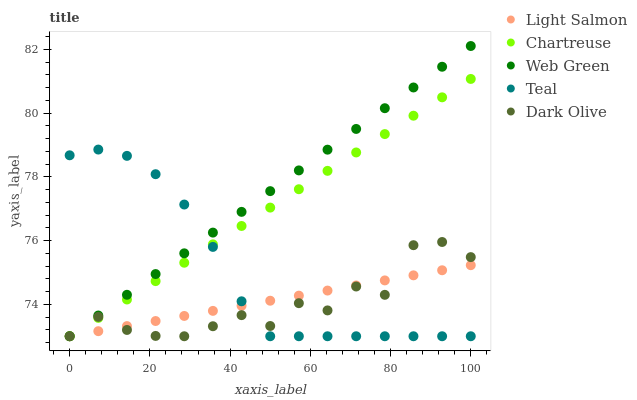Does Dark Olive have the minimum area under the curve?
Answer yes or no. Yes. Does Web Green have the maximum area under the curve?
Answer yes or no. Yes. Does Light Salmon have the minimum area under the curve?
Answer yes or no. No. Does Light Salmon have the maximum area under the curve?
Answer yes or no. No. Is Chartreuse the smoothest?
Answer yes or no. Yes. Is Dark Olive the roughest?
Answer yes or no. Yes. Is Light Salmon the smoothest?
Answer yes or no. No. Is Light Salmon the roughest?
Answer yes or no. No. Does Teal have the lowest value?
Answer yes or no. Yes. Does Web Green have the highest value?
Answer yes or no. Yes. Does Dark Olive have the highest value?
Answer yes or no. No. Does Chartreuse intersect Web Green?
Answer yes or no. Yes. Is Chartreuse less than Web Green?
Answer yes or no. No. Is Chartreuse greater than Web Green?
Answer yes or no. No. 